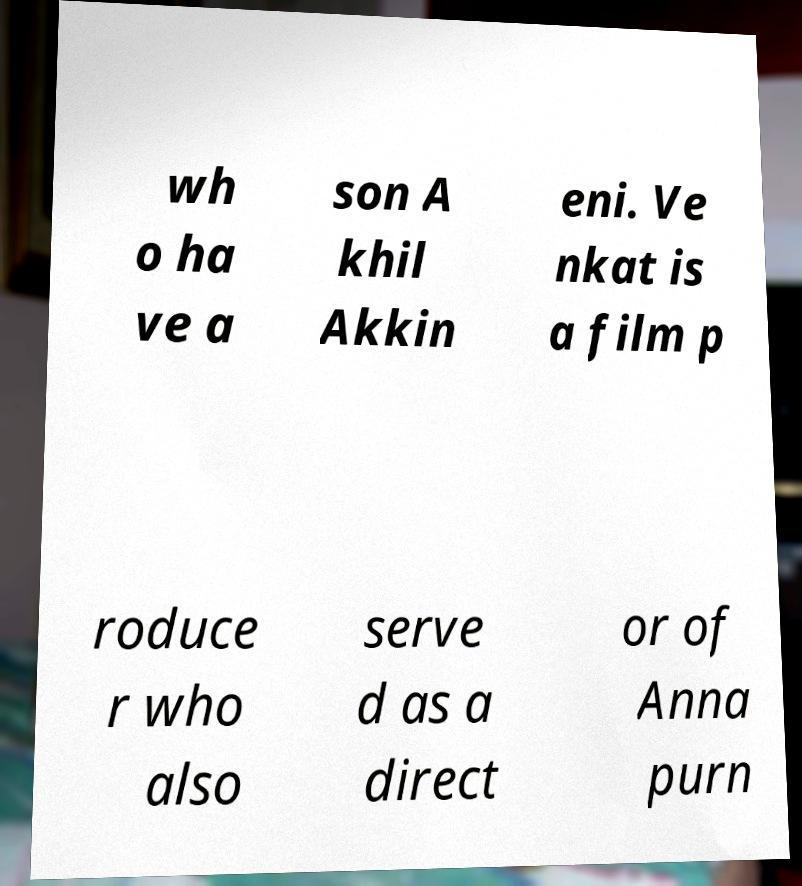I need the written content from this picture converted into text. Can you do that? wh o ha ve a son A khil Akkin eni. Ve nkat is a film p roduce r who also serve d as a direct or of Anna purn 